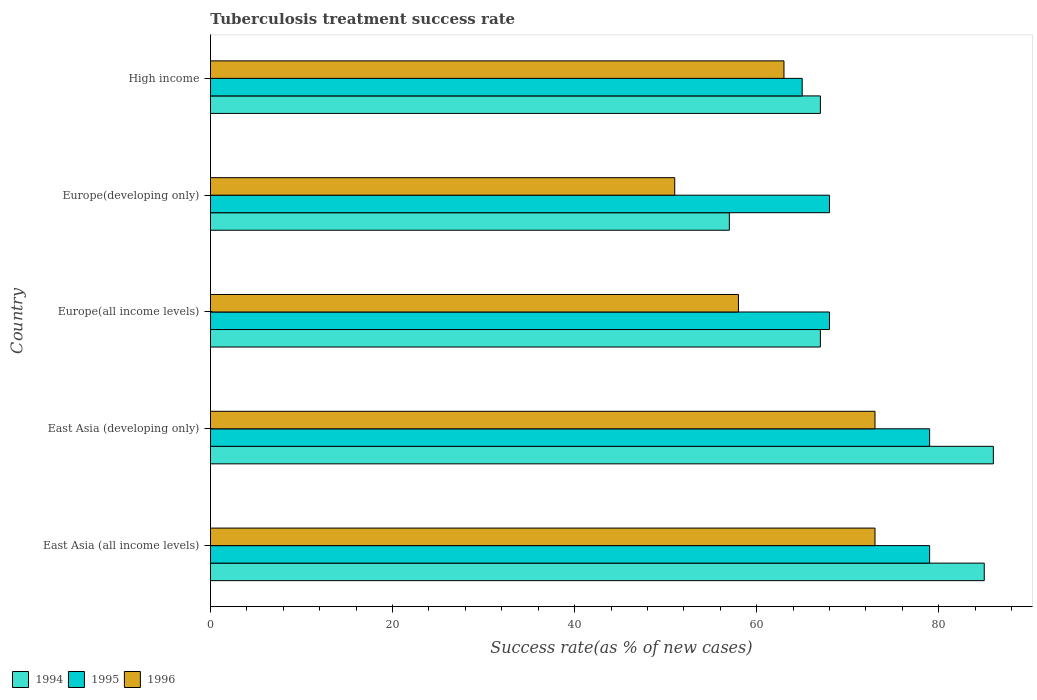How many different coloured bars are there?
Keep it short and to the point. 3. How many groups of bars are there?
Offer a very short reply. 5. Are the number of bars on each tick of the Y-axis equal?
Your response must be concise. Yes. What is the label of the 4th group of bars from the top?
Provide a succinct answer. East Asia (developing only). In how many cases, is the number of bars for a given country not equal to the number of legend labels?
Keep it short and to the point. 0. Across all countries, what is the maximum tuberculosis treatment success rate in 1994?
Your answer should be compact. 86. Across all countries, what is the minimum tuberculosis treatment success rate in 1996?
Your answer should be very brief. 51. In which country was the tuberculosis treatment success rate in 1995 maximum?
Provide a short and direct response. East Asia (all income levels). In which country was the tuberculosis treatment success rate in 1995 minimum?
Give a very brief answer. High income. What is the total tuberculosis treatment success rate in 1994 in the graph?
Offer a terse response. 362. What is the difference between the tuberculosis treatment success rate in 1995 in East Asia (all income levels) and that in Europe(developing only)?
Give a very brief answer. 11. What is the difference between the tuberculosis treatment success rate in 1995 in East Asia (all income levels) and the tuberculosis treatment success rate in 1996 in High income?
Your answer should be compact. 16. What is the average tuberculosis treatment success rate in 1996 per country?
Give a very brief answer. 63.6. What is the difference between the tuberculosis treatment success rate in 1994 and tuberculosis treatment success rate in 1995 in High income?
Make the answer very short. 2. In how many countries, is the tuberculosis treatment success rate in 1994 greater than 84 %?
Your answer should be compact. 2. Is the difference between the tuberculosis treatment success rate in 1994 in East Asia (all income levels) and Europe(all income levels) greater than the difference between the tuberculosis treatment success rate in 1995 in East Asia (all income levels) and Europe(all income levels)?
Your response must be concise. Yes. What is the difference between the highest and the second highest tuberculosis treatment success rate in 1995?
Your answer should be very brief. 0. What does the 3rd bar from the top in Europe(all income levels) represents?
Provide a succinct answer. 1994. What does the 1st bar from the bottom in High income represents?
Provide a short and direct response. 1994. How many bars are there?
Your answer should be very brief. 15. Are all the bars in the graph horizontal?
Give a very brief answer. Yes. How many countries are there in the graph?
Make the answer very short. 5. Are the values on the major ticks of X-axis written in scientific E-notation?
Keep it short and to the point. No. Does the graph contain grids?
Ensure brevity in your answer.  No. How many legend labels are there?
Your answer should be very brief. 3. How are the legend labels stacked?
Your response must be concise. Horizontal. What is the title of the graph?
Offer a terse response. Tuberculosis treatment success rate. What is the label or title of the X-axis?
Offer a very short reply. Success rate(as % of new cases). What is the label or title of the Y-axis?
Offer a very short reply. Country. What is the Success rate(as % of new cases) of 1995 in East Asia (all income levels)?
Ensure brevity in your answer.  79. What is the Success rate(as % of new cases) of 1996 in East Asia (all income levels)?
Your answer should be very brief. 73. What is the Success rate(as % of new cases) of 1994 in East Asia (developing only)?
Keep it short and to the point. 86. What is the Success rate(as % of new cases) of 1995 in East Asia (developing only)?
Offer a terse response. 79. What is the Success rate(as % of new cases) in 1994 in Europe(all income levels)?
Provide a succinct answer. 67. What is the Success rate(as % of new cases) of 1995 in Europe(all income levels)?
Your answer should be very brief. 68. What is the Success rate(as % of new cases) in 1994 in Europe(developing only)?
Your response must be concise. 57. What is the Success rate(as % of new cases) in 1995 in Europe(developing only)?
Your response must be concise. 68. What is the Success rate(as % of new cases) of 1996 in Europe(developing only)?
Your answer should be very brief. 51. What is the Success rate(as % of new cases) of 1994 in High income?
Offer a very short reply. 67. What is the Success rate(as % of new cases) of 1996 in High income?
Keep it short and to the point. 63. Across all countries, what is the maximum Success rate(as % of new cases) in 1994?
Offer a very short reply. 86. Across all countries, what is the maximum Success rate(as % of new cases) of 1995?
Give a very brief answer. 79. Across all countries, what is the minimum Success rate(as % of new cases) of 1995?
Offer a terse response. 65. Across all countries, what is the minimum Success rate(as % of new cases) of 1996?
Make the answer very short. 51. What is the total Success rate(as % of new cases) of 1994 in the graph?
Provide a succinct answer. 362. What is the total Success rate(as % of new cases) in 1995 in the graph?
Give a very brief answer. 359. What is the total Success rate(as % of new cases) of 1996 in the graph?
Provide a succinct answer. 318. What is the difference between the Success rate(as % of new cases) of 1994 in East Asia (all income levels) and that in East Asia (developing only)?
Your answer should be very brief. -1. What is the difference between the Success rate(as % of new cases) in 1995 in East Asia (all income levels) and that in East Asia (developing only)?
Offer a terse response. 0. What is the difference between the Success rate(as % of new cases) of 1994 in East Asia (all income levels) and that in Europe(all income levels)?
Your answer should be compact. 18. What is the difference between the Success rate(as % of new cases) in 1995 in East Asia (all income levels) and that in Europe(all income levels)?
Make the answer very short. 11. What is the difference between the Success rate(as % of new cases) in 1994 in East Asia (all income levels) and that in Europe(developing only)?
Give a very brief answer. 28. What is the difference between the Success rate(as % of new cases) in 1995 in East Asia (all income levels) and that in Europe(developing only)?
Your answer should be compact. 11. What is the difference between the Success rate(as % of new cases) in 1994 in East Asia (all income levels) and that in High income?
Your response must be concise. 18. What is the difference between the Success rate(as % of new cases) of 1996 in East Asia (all income levels) and that in High income?
Provide a short and direct response. 10. What is the difference between the Success rate(as % of new cases) of 1995 in East Asia (developing only) and that in Europe(all income levels)?
Keep it short and to the point. 11. What is the difference between the Success rate(as % of new cases) of 1996 in East Asia (developing only) and that in Europe(all income levels)?
Give a very brief answer. 15. What is the difference between the Success rate(as % of new cases) in 1996 in East Asia (developing only) and that in Europe(developing only)?
Your answer should be very brief. 22. What is the difference between the Success rate(as % of new cases) in 1994 in East Asia (developing only) and that in High income?
Offer a very short reply. 19. What is the difference between the Success rate(as % of new cases) in 1995 in East Asia (developing only) and that in High income?
Your answer should be very brief. 14. What is the difference between the Success rate(as % of new cases) of 1996 in Europe(all income levels) and that in Europe(developing only)?
Make the answer very short. 7. What is the difference between the Success rate(as % of new cases) in 1995 in Europe(developing only) and that in High income?
Your response must be concise. 3. What is the difference between the Success rate(as % of new cases) of 1994 in East Asia (all income levels) and the Success rate(as % of new cases) of 1995 in East Asia (developing only)?
Provide a succinct answer. 6. What is the difference between the Success rate(as % of new cases) of 1995 in East Asia (all income levels) and the Success rate(as % of new cases) of 1996 in East Asia (developing only)?
Offer a terse response. 6. What is the difference between the Success rate(as % of new cases) in 1994 in East Asia (all income levels) and the Success rate(as % of new cases) in 1995 in Europe(all income levels)?
Your answer should be compact. 17. What is the difference between the Success rate(as % of new cases) in 1994 in East Asia (all income levels) and the Success rate(as % of new cases) in 1996 in Europe(developing only)?
Give a very brief answer. 34. What is the difference between the Success rate(as % of new cases) in 1994 in East Asia (all income levels) and the Success rate(as % of new cases) in 1995 in High income?
Offer a very short reply. 20. What is the difference between the Success rate(as % of new cases) in 1994 in East Asia (all income levels) and the Success rate(as % of new cases) in 1996 in High income?
Keep it short and to the point. 22. What is the difference between the Success rate(as % of new cases) in 1994 in East Asia (developing only) and the Success rate(as % of new cases) in 1995 in Europe(all income levels)?
Ensure brevity in your answer.  18. What is the difference between the Success rate(as % of new cases) of 1994 in East Asia (developing only) and the Success rate(as % of new cases) of 1996 in Europe(all income levels)?
Your answer should be compact. 28. What is the difference between the Success rate(as % of new cases) of 1994 in East Asia (developing only) and the Success rate(as % of new cases) of 1995 in Europe(developing only)?
Your answer should be very brief. 18. What is the difference between the Success rate(as % of new cases) in 1994 in East Asia (developing only) and the Success rate(as % of new cases) in 1995 in High income?
Your answer should be very brief. 21. What is the difference between the Success rate(as % of new cases) of 1994 in Europe(all income levels) and the Success rate(as % of new cases) of 1995 in Europe(developing only)?
Your answer should be compact. -1. What is the difference between the Success rate(as % of new cases) of 1994 in Europe(all income levels) and the Success rate(as % of new cases) of 1996 in Europe(developing only)?
Offer a terse response. 16. What is the difference between the Success rate(as % of new cases) in 1995 in Europe(all income levels) and the Success rate(as % of new cases) in 1996 in Europe(developing only)?
Provide a succinct answer. 17. What is the difference between the Success rate(as % of new cases) in 1995 in Europe(all income levels) and the Success rate(as % of new cases) in 1996 in High income?
Ensure brevity in your answer.  5. What is the difference between the Success rate(as % of new cases) of 1994 in Europe(developing only) and the Success rate(as % of new cases) of 1996 in High income?
Keep it short and to the point. -6. What is the difference between the Success rate(as % of new cases) in 1995 in Europe(developing only) and the Success rate(as % of new cases) in 1996 in High income?
Your answer should be compact. 5. What is the average Success rate(as % of new cases) in 1994 per country?
Keep it short and to the point. 72.4. What is the average Success rate(as % of new cases) of 1995 per country?
Your answer should be compact. 71.8. What is the average Success rate(as % of new cases) of 1996 per country?
Your response must be concise. 63.6. What is the difference between the Success rate(as % of new cases) in 1994 and Success rate(as % of new cases) in 1996 in East Asia (all income levels)?
Your answer should be compact. 12. What is the difference between the Success rate(as % of new cases) of 1994 and Success rate(as % of new cases) of 1996 in East Asia (developing only)?
Provide a short and direct response. 13. What is the difference between the Success rate(as % of new cases) in 1994 and Success rate(as % of new cases) in 1995 in Europe(all income levels)?
Provide a short and direct response. -1. What is the difference between the Success rate(as % of new cases) in 1994 and Success rate(as % of new cases) in 1996 in Europe(developing only)?
Ensure brevity in your answer.  6. What is the difference between the Success rate(as % of new cases) in 1995 and Success rate(as % of new cases) in 1996 in Europe(developing only)?
Provide a short and direct response. 17. What is the difference between the Success rate(as % of new cases) of 1994 and Success rate(as % of new cases) of 1996 in High income?
Provide a short and direct response. 4. What is the difference between the Success rate(as % of new cases) in 1995 and Success rate(as % of new cases) in 1996 in High income?
Offer a very short reply. 2. What is the ratio of the Success rate(as % of new cases) in 1994 in East Asia (all income levels) to that in East Asia (developing only)?
Your answer should be very brief. 0.99. What is the ratio of the Success rate(as % of new cases) of 1995 in East Asia (all income levels) to that in East Asia (developing only)?
Provide a short and direct response. 1. What is the ratio of the Success rate(as % of new cases) in 1994 in East Asia (all income levels) to that in Europe(all income levels)?
Your answer should be compact. 1.27. What is the ratio of the Success rate(as % of new cases) in 1995 in East Asia (all income levels) to that in Europe(all income levels)?
Your answer should be compact. 1.16. What is the ratio of the Success rate(as % of new cases) in 1996 in East Asia (all income levels) to that in Europe(all income levels)?
Your answer should be very brief. 1.26. What is the ratio of the Success rate(as % of new cases) in 1994 in East Asia (all income levels) to that in Europe(developing only)?
Offer a very short reply. 1.49. What is the ratio of the Success rate(as % of new cases) of 1995 in East Asia (all income levels) to that in Europe(developing only)?
Ensure brevity in your answer.  1.16. What is the ratio of the Success rate(as % of new cases) of 1996 in East Asia (all income levels) to that in Europe(developing only)?
Provide a short and direct response. 1.43. What is the ratio of the Success rate(as % of new cases) of 1994 in East Asia (all income levels) to that in High income?
Provide a succinct answer. 1.27. What is the ratio of the Success rate(as % of new cases) of 1995 in East Asia (all income levels) to that in High income?
Offer a terse response. 1.22. What is the ratio of the Success rate(as % of new cases) of 1996 in East Asia (all income levels) to that in High income?
Your answer should be very brief. 1.16. What is the ratio of the Success rate(as % of new cases) of 1994 in East Asia (developing only) to that in Europe(all income levels)?
Offer a very short reply. 1.28. What is the ratio of the Success rate(as % of new cases) in 1995 in East Asia (developing only) to that in Europe(all income levels)?
Offer a very short reply. 1.16. What is the ratio of the Success rate(as % of new cases) in 1996 in East Asia (developing only) to that in Europe(all income levels)?
Make the answer very short. 1.26. What is the ratio of the Success rate(as % of new cases) of 1994 in East Asia (developing only) to that in Europe(developing only)?
Your response must be concise. 1.51. What is the ratio of the Success rate(as % of new cases) of 1995 in East Asia (developing only) to that in Europe(developing only)?
Your answer should be compact. 1.16. What is the ratio of the Success rate(as % of new cases) of 1996 in East Asia (developing only) to that in Europe(developing only)?
Offer a very short reply. 1.43. What is the ratio of the Success rate(as % of new cases) of 1994 in East Asia (developing only) to that in High income?
Your answer should be very brief. 1.28. What is the ratio of the Success rate(as % of new cases) of 1995 in East Asia (developing only) to that in High income?
Your answer should be compact. 1.22. What is the ratio of the Success rate(as % of new cases) of 1996 in East Asia (developing only) to that in High income?
Offer a very short reply. 1.16. What is the ratio of the Success rate(as % of new cases) in 1994 in Europe(all income levels) to that in Europe(developing only)?
Provide a short and direct response. 1.18. What is the ratio of the Success rate(as % of new cases) of 1996 in Europe(all income levels) to that in Europe(developing only)?
Make the answer very short. 1.14. What is the ratio of the Success rate(as % of new cases) in 1995 in Europe(all income levels) to that in High income?
Give a very brief answer. 1.05. What is the ratio of the Success rate(as % of new cases) of 1996 in Europe(all income levels) to that in High income?
Provide a succinct answer. 0.92. What is the ratio of the Success rate(as % of new cases) in 1994 in Europe(developing only) to that in High income?
Your answer should be very brief. 0.85. What is the ratio of the Success rate(as % of new cases) of 1995 in Europe(developing only) to that in High income?
Provide a short and direct response. 1.05. What is the ratio of the Success rate(as % of new cases) of 1996 in Europe(developing only) to that in High income?
Give a very brief answer. 0.81. What is the difference between the highest and the second highest Success rate(as % of new cases) in 1994?
Your answer should be very brief. 1. What is the difference between the highest and the lowest Success rate(as % of new cases) in 1995?
Your answer should be very brief. 14. What is the difference between the highest and the lowest Success rate(as % of new cases) of 1996?
Give a very brief answer. 22. 